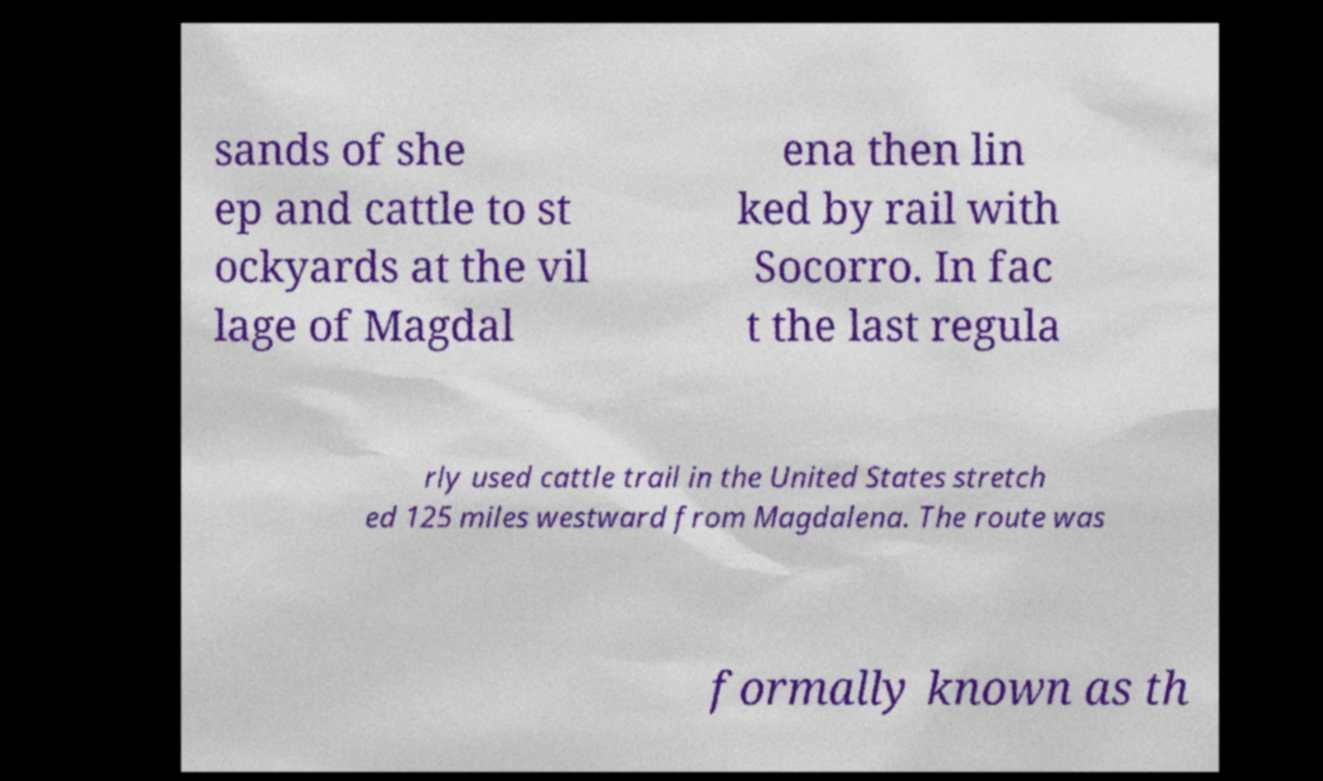Can you accurately transcribe the text from the provided image for me? sands of she ep and cattle to st ockyards at the vil lage of Magdal ena then lin ked by rail with Socorro. In fac t the last regula rly used cattle trail in the United States stretch ed 125 miles westward from Magdalena. The route was formally known as th 